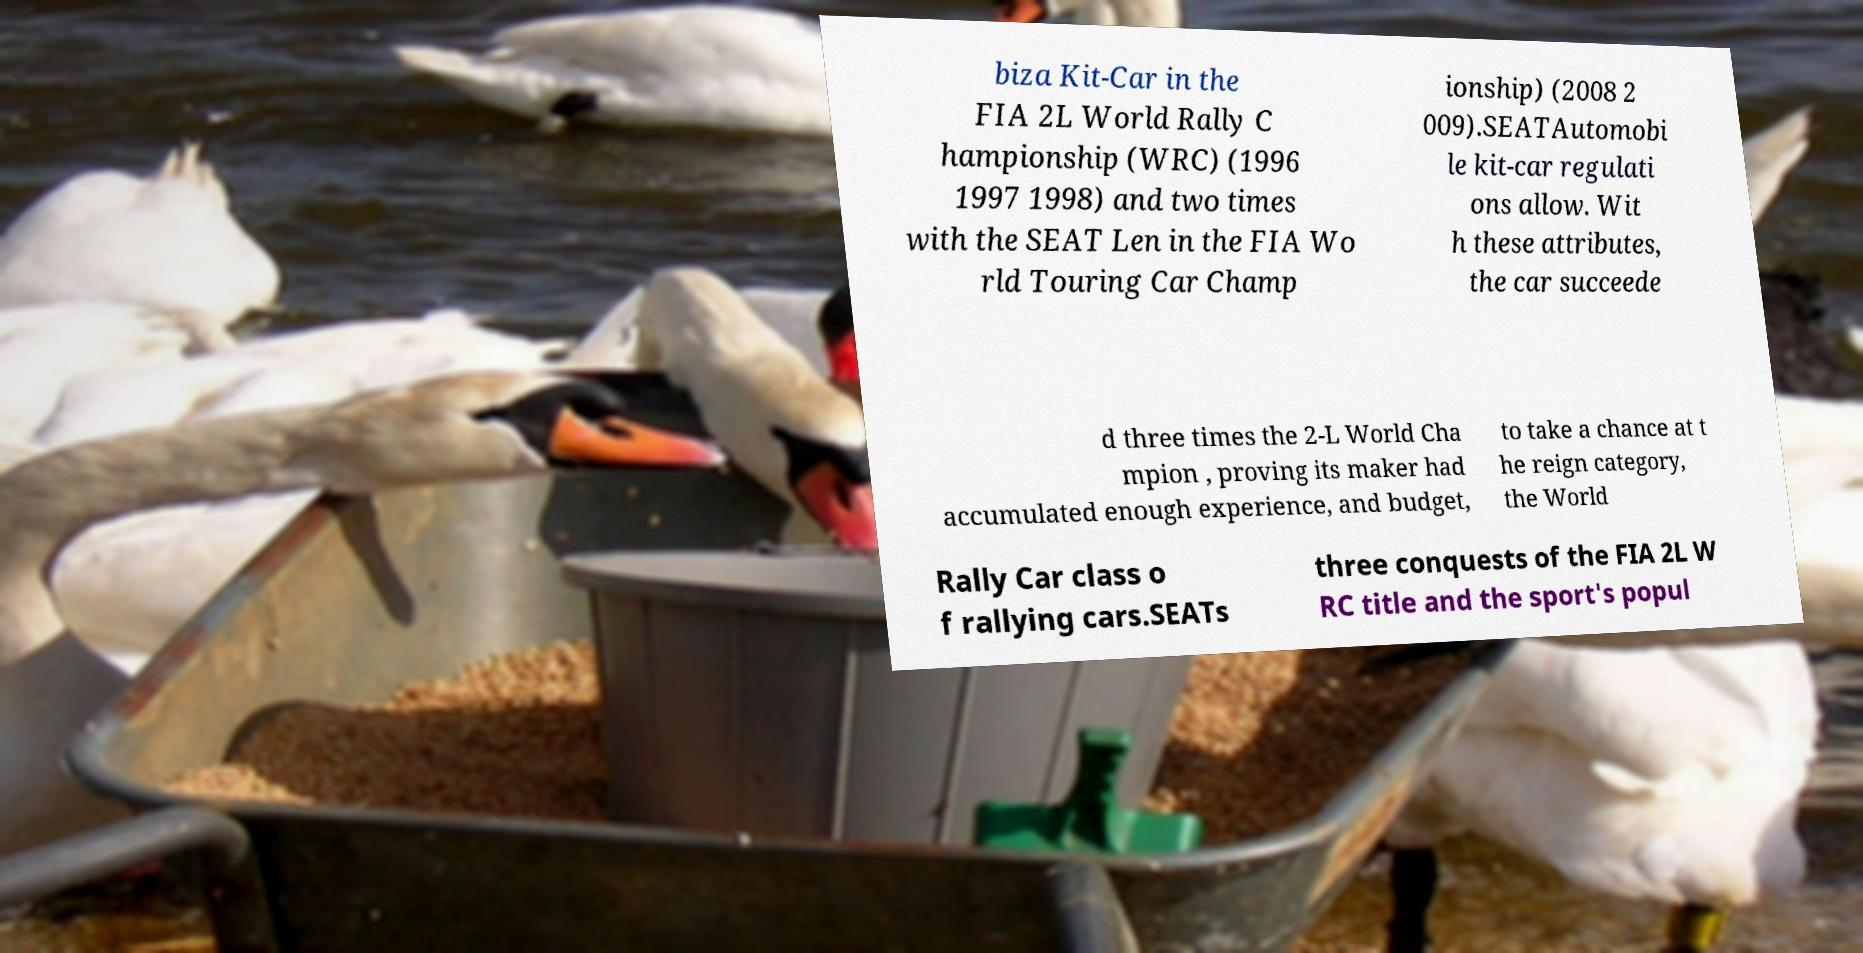For documentation purposes, I need the text within this image transcribed. Could you provide that? biza Kit-Car in the FIA 2L World Rally C hampionship (WRC) (1996 1997 1998) and two times with the SEAT Len in the FIA Wo rld Touring Car Champ ionship) (2008 2 009).SEATAutomobi le kit-car regulati ons allow. Wit h these attributes, the car succeede d three times the 2-L World Cha mpion , proving its maker had accumulated enough experience, and budget, to take a chance at t he reign category, the World Rally Car class o f rallying cars.SEATs three conquests of the FIA 2L W RC title and the sport's popul 